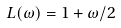Convert formula to latex. <formula><loc_0><loc_0><loc_500><loc_500>L ( \omega ) = 1 + \omega / 2</formula> 